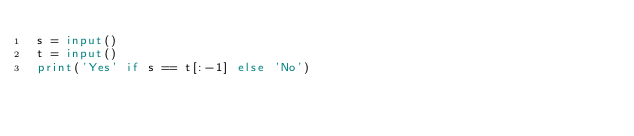<code> <loc_0><loc_0><loc_500><loc_500><_Python_>s = input()
t = input()
print('Yes' if s == t[:-1] else 'No')</code> 